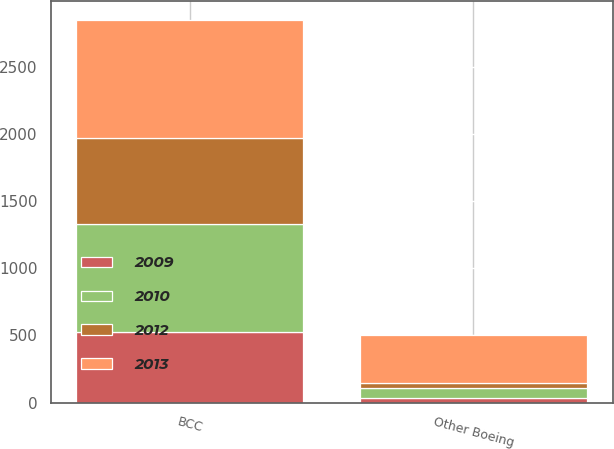<chart> <loc_0><loc_0><loc_500><loc_500><stacked_bar_chart><ecel><fcel>BCC<fcel>Other Boeing<nl><fcel>2009<fcel>528<fcel>32<nl><fcel>2012<fcel>645<fcel>37<nl><fcel>2010<fcel>798<fcel>73<nl><fcel>2013<fcel>878<fcel>363<nl></chart> 